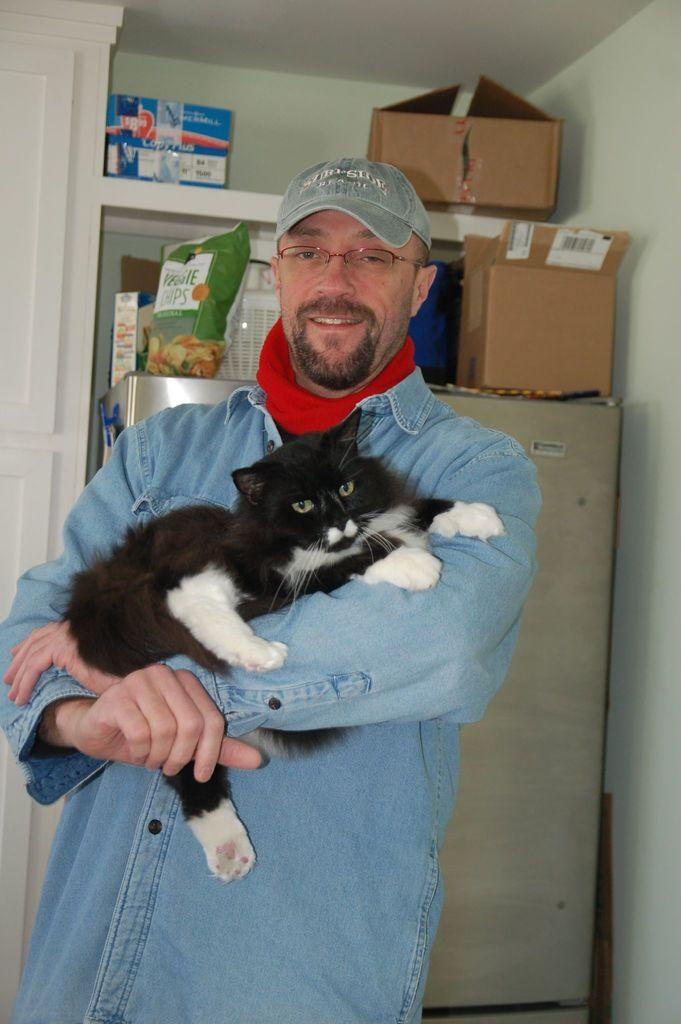Who is present in the image? There is a man in the image. What is the man doing in the image? The man is standing in the image. What is the man holding in the image? The man is holding a black color cat in the image. What accessory is the man wearing in the image? The man is wearing a hat in the image. What can be seen in the background of the image? There are two carton boxes in the background of the image. What time does the person in the image lead the group? There is no indication of time or a group in the image; it only features a man holding a black color cat. 